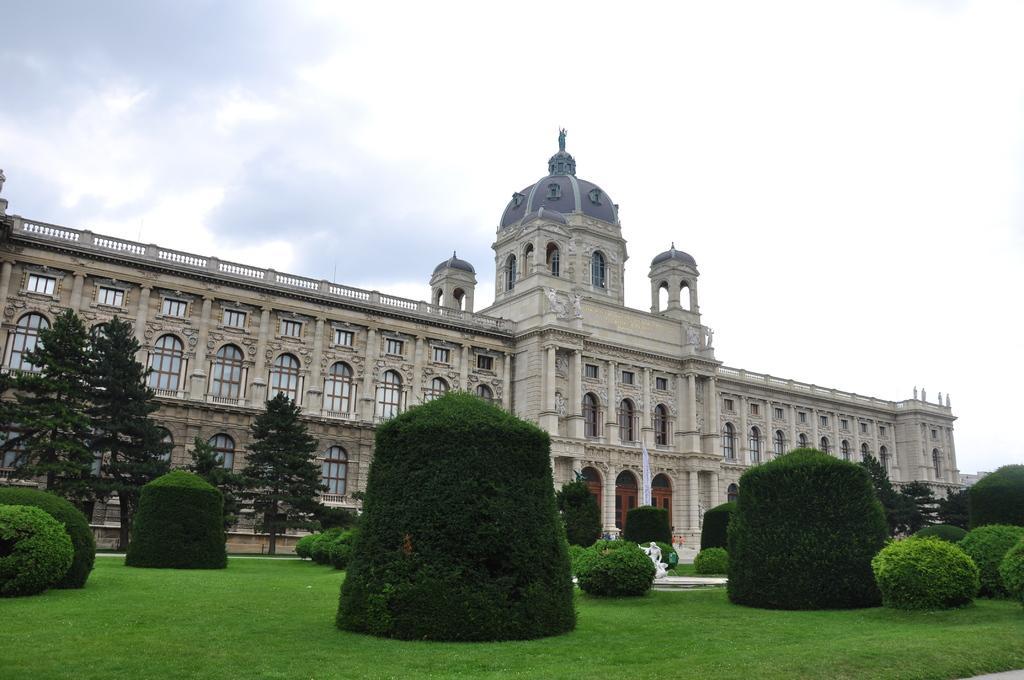Could you give a brief overview of what you see in this image? In this image, we can see a building, there is green grass on the ground, there are some plants and trees, at the top there is a sky. 